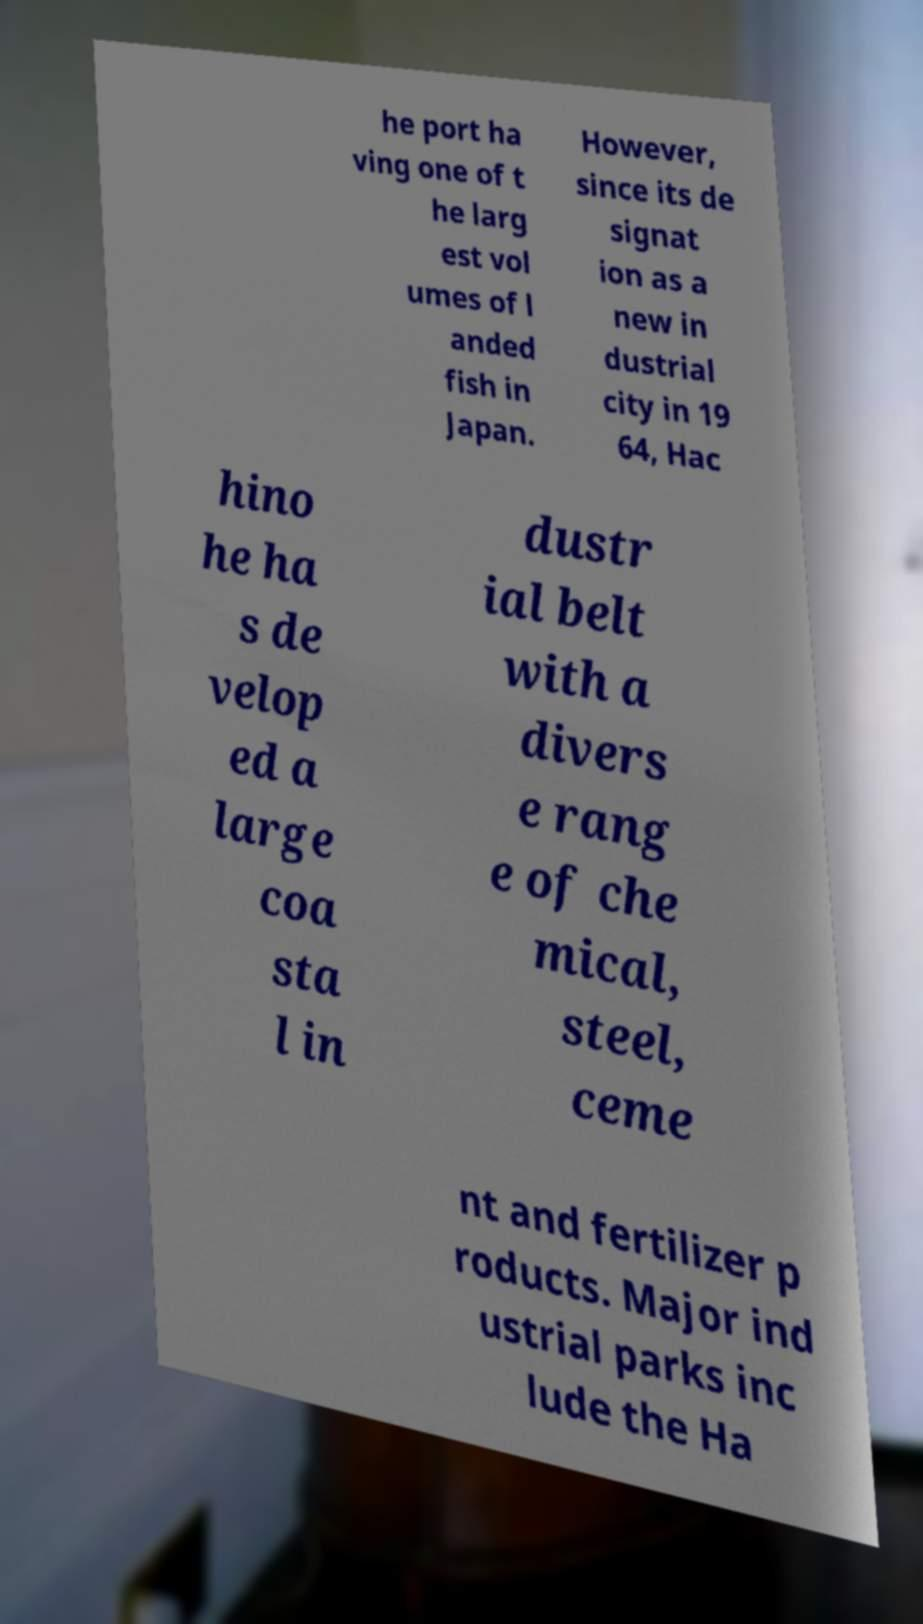Can you accurately transcribe the text from the provided image for me? he port ha ving one of t he larg est vol umes of l anded fish in Japan. However, since its de signat ion as a new in dustrial city in 19 64, Hac hino he ha s de velop ed a large coa sta l in dustr ial belt with a divers e rang e of che mical, steel, ceme nt and fertilizer p roducts. Major ind ustrial parks inc lude the Ha 